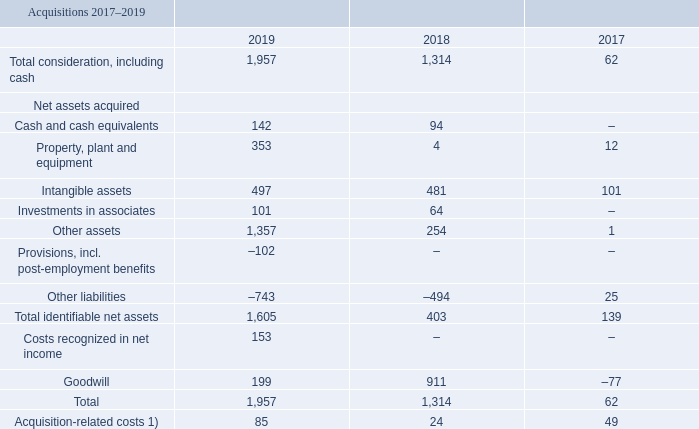Acquisitions and divestments
Acquisitions
In 2019, Ericsson made acquisitions with a negative cash flow effect amounting to SEK 1,815 (1,220) million. The acquisitions presented below are not material, but the Company gives the information to provide the reader a summarized view of the content of the acquisitions made. The acquisitions consist primarily of:
Kathrein: On October 2, 2019, the Company acquired assets from Kathrein, a world leading provider of antenna and filter technologies with approximately 4,000 employees. Kathrein’s antenna and filters business has a strong R&D organization with extensive experience in antenna design and research, coupled with a strong IPR portfolio. In addition to broadening Ericsson’s portfolio of antenna and filter products, the acquisition will bring vital competence for the evolution of advanced radio network products. The acquired Kathrein business has had a negative impact of SEK –0.5 billion since the acquisition, corresponding to –1 percentage point in Networks operating margin. Balances to facilitate the Purchase price allocation are preliminary.
CSF: On August 20, 2019, the Company acquired 100% of the shares in CSF Holdings Inc. a US-based technology company with approximately 25 employees. CSF strengthens iconectiv’s Business to Consumer (B2C) product platforms to enable growth in messaging and Toll-Free Number (TFN) management. Balances to facilitate the Purchase price allocation are final.
ST-Ericsson: Before ST-Ericsson was a joint venture where Ericsson and ST Microelectronics had a 50/50 ownership. This joint venture consisted of a number of legal entities where the two parties owned different stakes in the different legal entities. In December 2019 the Company initiated transactions to wind-down the legal structure of ST-Ericsson by acquiring the remaining shares in two legal ST-Ericsson entities and costs of SEK –0.3 billion impacted the result. The Company now owns 100% of the shares in those entities.
In order to finalize a Purchase price allocation all relevant information needs to be in place. Examples of such information are final consideration and final opening balances, they may remain preliminary for a period of time due
to for example adjustments of working capital, tax items or decisions from local authorities.
1) Acquisition-related costs are included in Selling and administrative expenses in the consolidated income statement.
What is the total consideration for 2017?
Answer scale should be: million. 62. How many employees are in Kathrein? Approximately 4,000. When is CSF being acquired? August 20, 2019. What is the change in cash and cash equivalents between 2019 and 2018?
Answer scale should be: million. 142-94
Answer: 48. What is the total acquisition-related costs from 2017 to 2019?
Answer scale should be: million. 85+24+49
Answer: 158. What is the change in total consideration between 2019 and 2018?
Answer scale should be: million. 1,957-1,314
Answer: 643. 